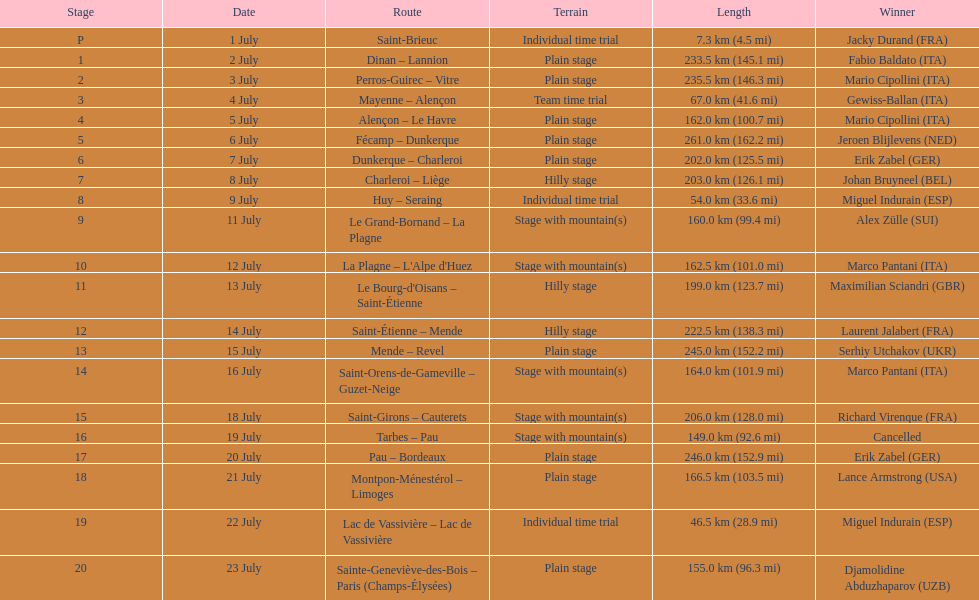How many routes cover less than 100 km in total? 4. 